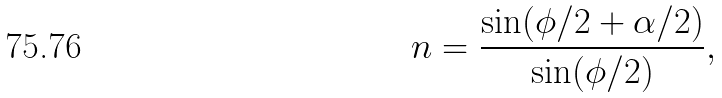Convert formula to latex. <formula><loc_0><loc_0><loc_500><loc_500>n = \frac { \sin ( \phi / 2 + \alpha / 2 ) } { \sin ( \phi / 2 ) } ,</formula> 